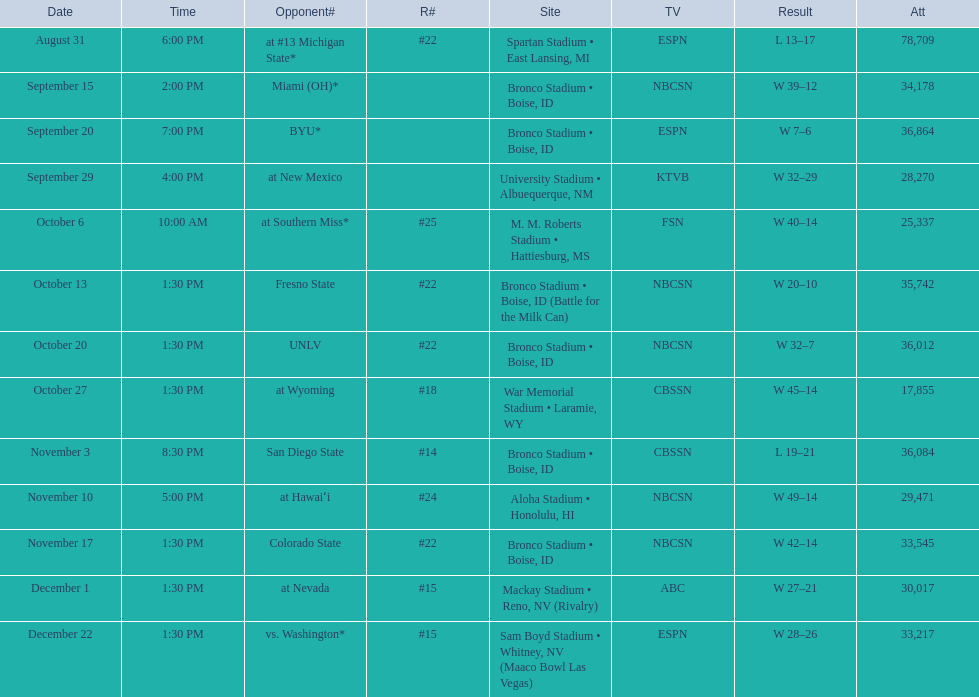Opponent broncos faced next after unlv Wyoming. 